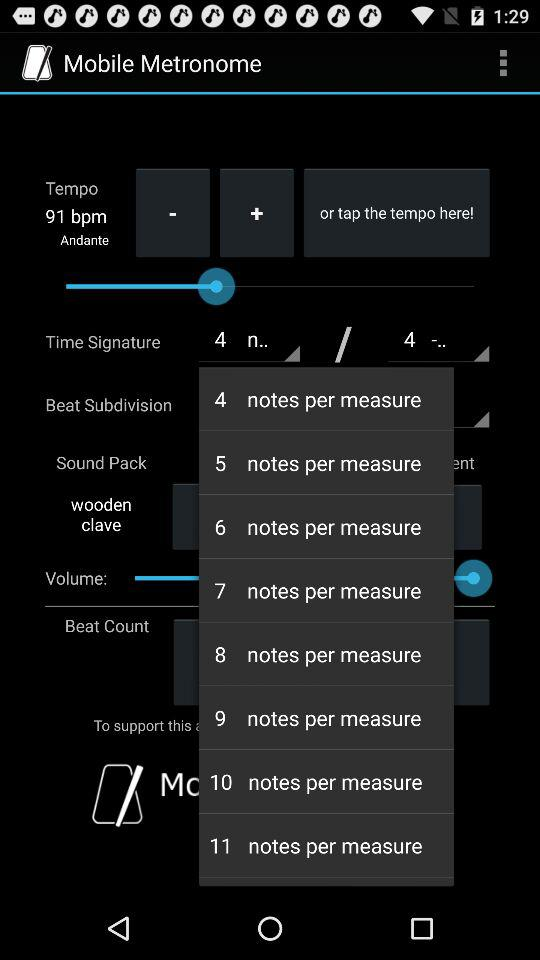What's the Time signature?
When the provided information is insufficient, respond with <no answer>. <no answer> 